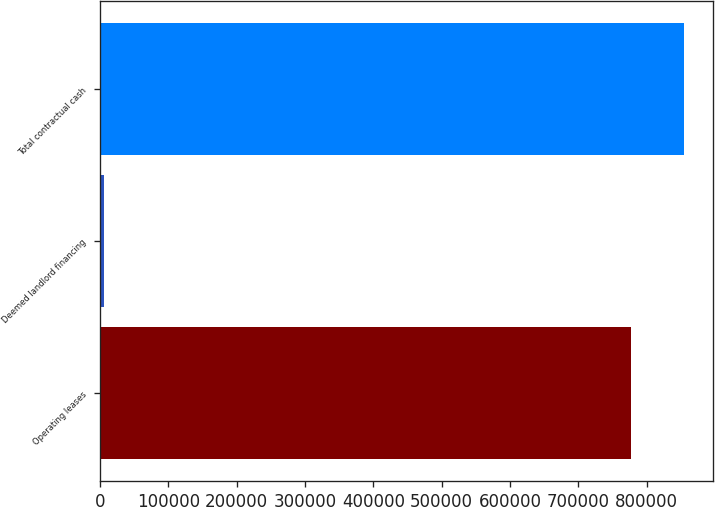Convert chart. <chart><loc_0><loc_0><loc_500><loc_500><bar_chart><fcel>Operating leases<fcel>Deemed landlord financing<fcel>Total contractual cash<nl><fcel>776477<fcel>5868<fcel>854125<nl></chart> 